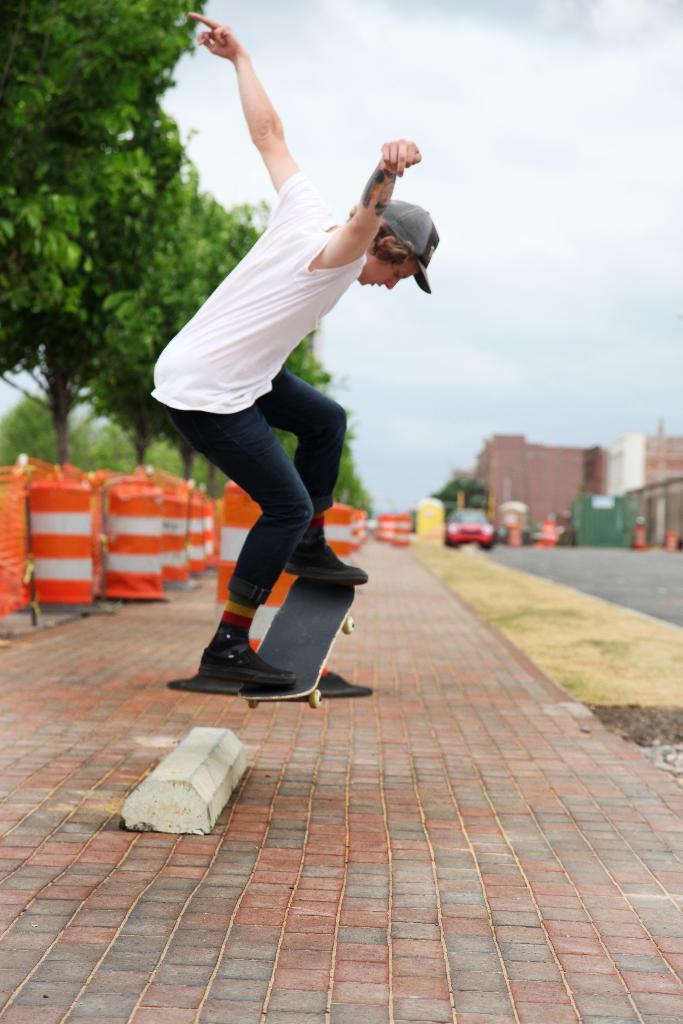How would you summarize this image in a sentence or two? In this image we can see a person wearing the cap and skating with the skateboard. We can also see the safety pillars, path, vehicles, trees, buildings and also the cloudy sky. 